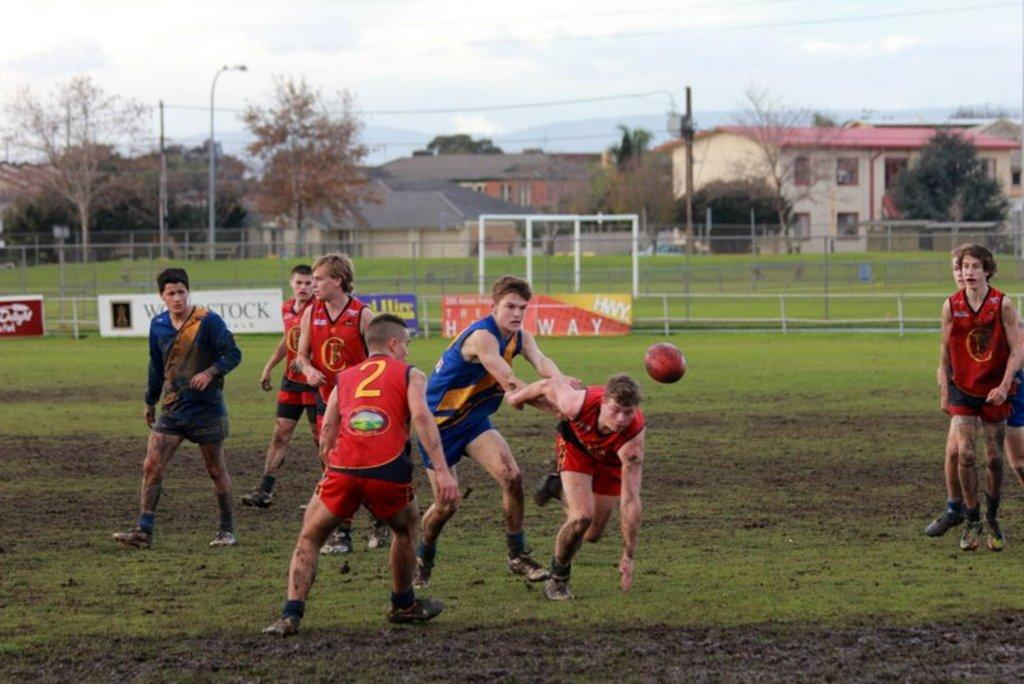<image>
Render a clear and concise summary of the photo. A game of rugby is played on a very muddy field by youths in front of a hoarding advertising woodstock. 